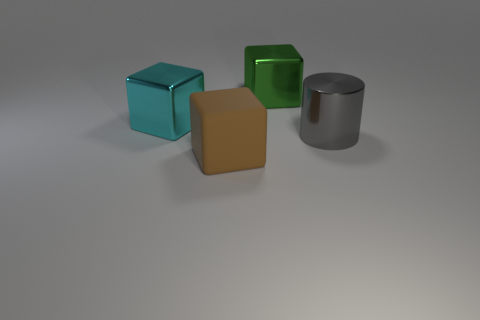What color is the block that is to the right of the large brown thing to the left of the green metal cube?
Keep it short and to the point. Green. How many other objects are there of the same material as the brown thing?
Offer a very short reply. 0. How many large cubes are left of the large thing that is in front of the big gray object?
Provide a short and direct response. 1. Is there anything else that has the same shape as the gray metal object?
Make the answer very short. No. Does the cube in front of the big cyan cube have the same color as the big cube that is left of the brown thing?
Make the answer very short. No. Are there fewer big gray metallic objects than big shiny balls?
Your response must be concise. No. There is a large object behind the large shiny block that is in front of the green metal object; what shape is it?
Ensure brevity in your answer.  Cube. Is there anything else that has the same size as the cyan block?
Give a very brief answer. Yes. What shape is the big shiny thing that is in front of the large object that is on the left side of the block that is in front of the big gray metallic cylinder?
Offer a terse response. Cylinder. How many objects are cubes behind the large brown rubber thing or blocks in front of the large shiny cylinder?
Your answer should be very brief. 3. 